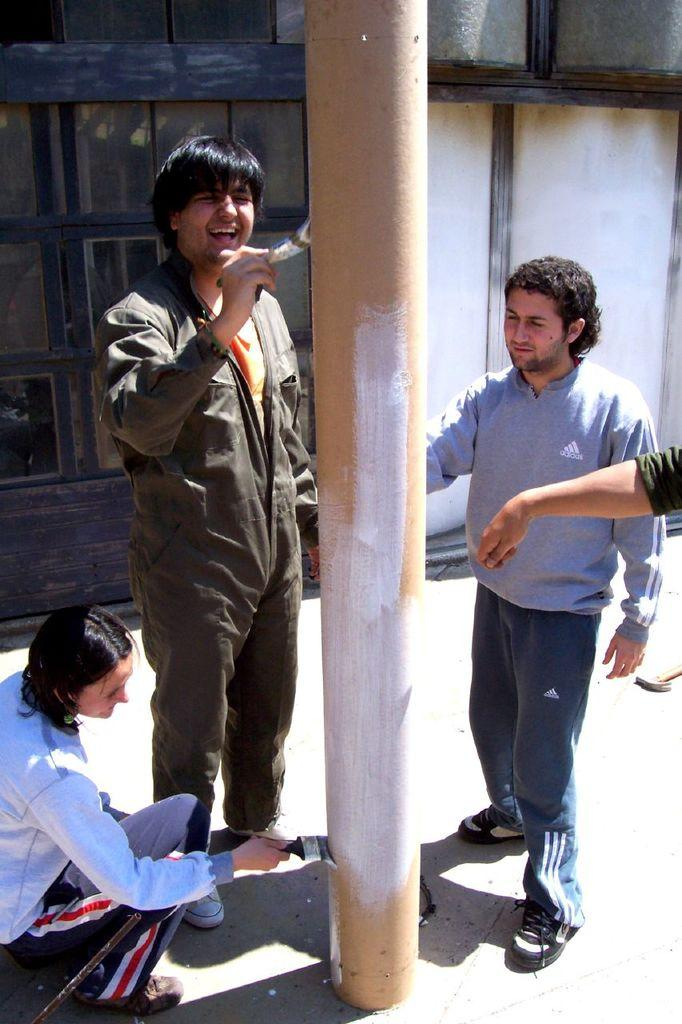What is the main object in the image? There is a pole in the image. What are the people in the image doing? A group of people are painting the pole. Can you describe any other features in the image? There is a window visible in the image. How much snow can be seen on the tray in the image? There is no tray or snow present in the image. What type of crush is happening near the pole in the image? There is no crush or any related activity happening near the pole in the image. 